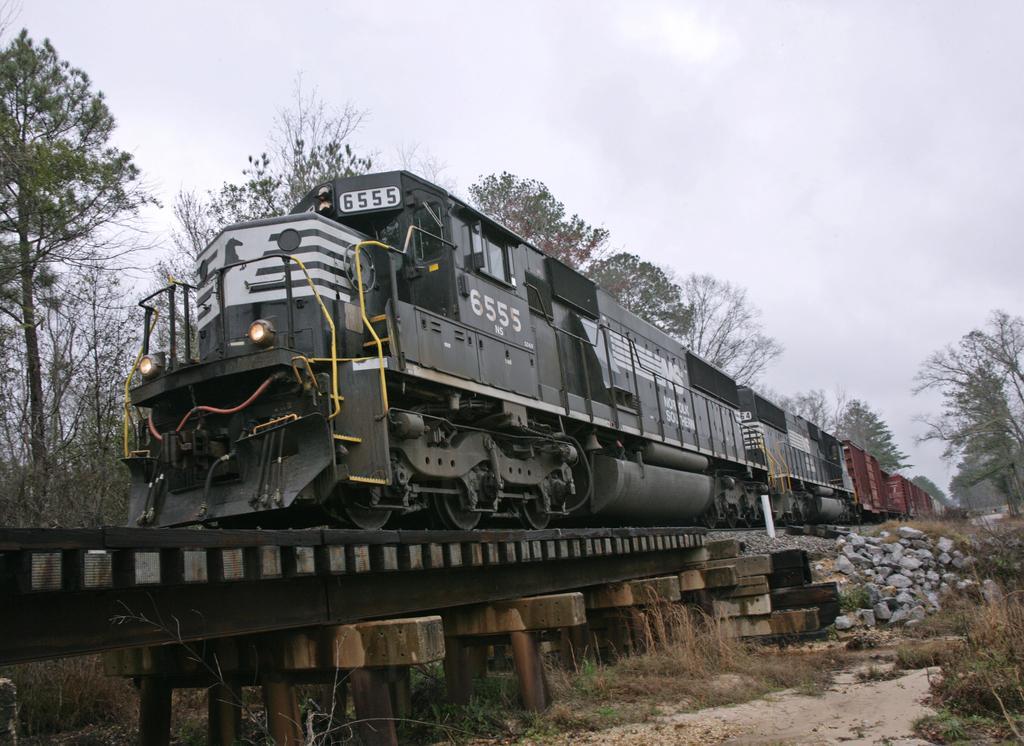Describe this image in one or two sentences. In the foreground of this image, there is a train on the track. We can also see few stones, grass, trees and the cloud. 